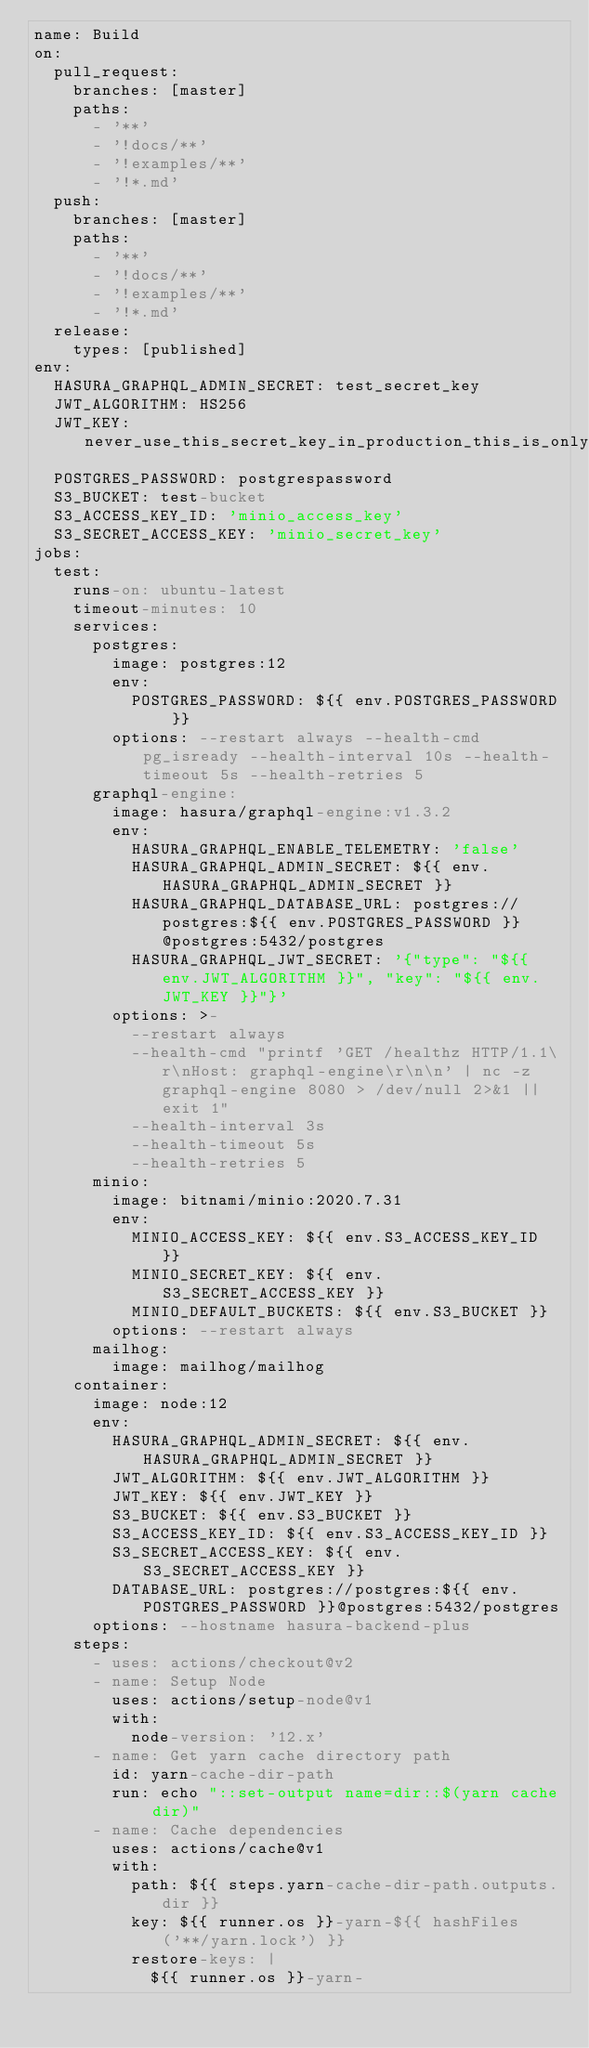<code> <loc_0><loc_0><loc_500><loc_500><_YAML_>name: Build
on:
  pull_request:
    branches: [master]
    paths:
      - '**'
      - '!docs/**'
      - '!examples/**'
      - '!*.md'
  push:
    branches: [master]
    paths:
      - '**'
      - '!docs/**'
      - '!examples/**'
      - '!*.md'
  release:
    types: [published]
env:
  HASURA_GRAPHQL_ADMIN_SECRET: test_secret_key
  JWT_ALGORITHM: HS256
  JWT_KEY: never_use_this_secret_key_in_production_this_is_only_for_CI_testing_098hu32r4389ufb4n38994321
  POSTGRES_PASSWORD: postgrespassword
  S3_BUCKET: test-bucket
  S3_ACCESS_KEY_ID: 'minio_access_key'
  S3_SECRET_ACCESS_KEY: 'minio_secret_key'
jobs:
  test:
    runs-on: ubuntu-latest
    timeout-minutes: 10
    services:
      postgres:
        image: postgres:12
        env:
          POSTGRES_PASSWORD: ${{ env.POSTGRES_PASSWORD }}
        options: --restart always --health-cmd pg_isready --health-interval 10s --health-timeout 5s --health-retries 5
      graphql-engine:
        image: hasura/graphql-engine:v1.3.2
        env:
          HASURA_GRAPHQL_ENABLE_TELEMETRY: 'false'
          HASURA_GRAPHQL_ADMIN_SECRET: ${{ env.HASURA_GRAPHQL_ADMIN_SECRET }}
          HASURA_GRAPHQL_DATABASE_URL: postgres://postgres:${{ env.POSTGRES_PASSWORD }}@postgres:5432/postgres
          HASURA_GRAPHQL_JWT_SECRET: '{"type": "${{ env.JWT_ALGORITHM }}", "key": "${{ env.JWT_KEY }}"}'
        options: >-
          --restart always
          --health-cmd "printf 'GET /healthz HTTP/1.1\r\nHost: graphql-engine\r\n\n' | nc -z graphql-engine 8080 > /dev/null 2>&1 || exit 1"
          --health-interval 3s
          --health-timeout 5s
          --health-retries 5
      minio:
        image: bitnami/minio:2020.7.31
        env:
          MINIO_ACCESS_KEY: ${{ env.S3_ACCESS_KEY_ID }}
          MINIO_SECRET_KEY: ${{ env.S3_SECRET_ACCESS_KEY }}
          MINIO_DEFAULT_BUCKETS: ${{ env.S3_BUCKET }}
        options: --restart always
      mailhog:
        image: mailhog/mailhog
    container:
      image: node:12
      env:
        HASURA_GRAPHQL_ADMIN_SECRET: ${{ env.HASURA_GRAPHQL_ADMIN_SECRET }}
        JWT_ALGORITHM: ${{ env.JWT_ALGORITHM }}
        JWT_KEY: ${{ env.JWT_KEY }}
        S3_BUCKET: ${{ env.S3_BUCKET }}
        S3_ACCESS_KEY_ID: ${{ env.S3_ACCESS_KEY_ID }}
        S3_SECRET_ACCESS_KEY: ${{ env.S3_SECRET_ACCESS_KEY }}
        DATABASE_URL: postgres://postgres:${{ env.POSTGRES_PASSWORD }}@postgres:5432/postgres
      options: --hostname hasura-backend-plus
    steps:
      - uses: actions/checkout@v2
      - name: Setup Node
        uses: actions/setup-node@v1
        with:
          node-version: '12.x'
      - name: Get yarn cache directory path
        id: yarn-cache-dir-path
        run: echo "::set-output name=dir::$(yarn cache dir)"
      - name: Cache dependencies
        uses: actions/cache@v1
        with:
          path: ${{ steps.yarn-cache-dir-path.outputs.dir }}
          key: ${{ runner.os }}-yarn-${{ hashFiles('**/yarn.lock') }}
          restore-keys: |
            ${{ runner.os }}-yarn-</code> 